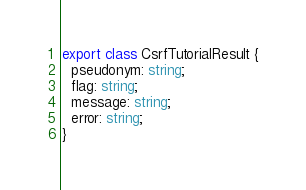Convert code to text. <code><loc_0><loc_0><loc_500><loc_500><_TypeScript_>export class CsrfTutorialResult {
  pseudonym: string;
  flag: string;
  message: string;
  error: string;
}
</code> 